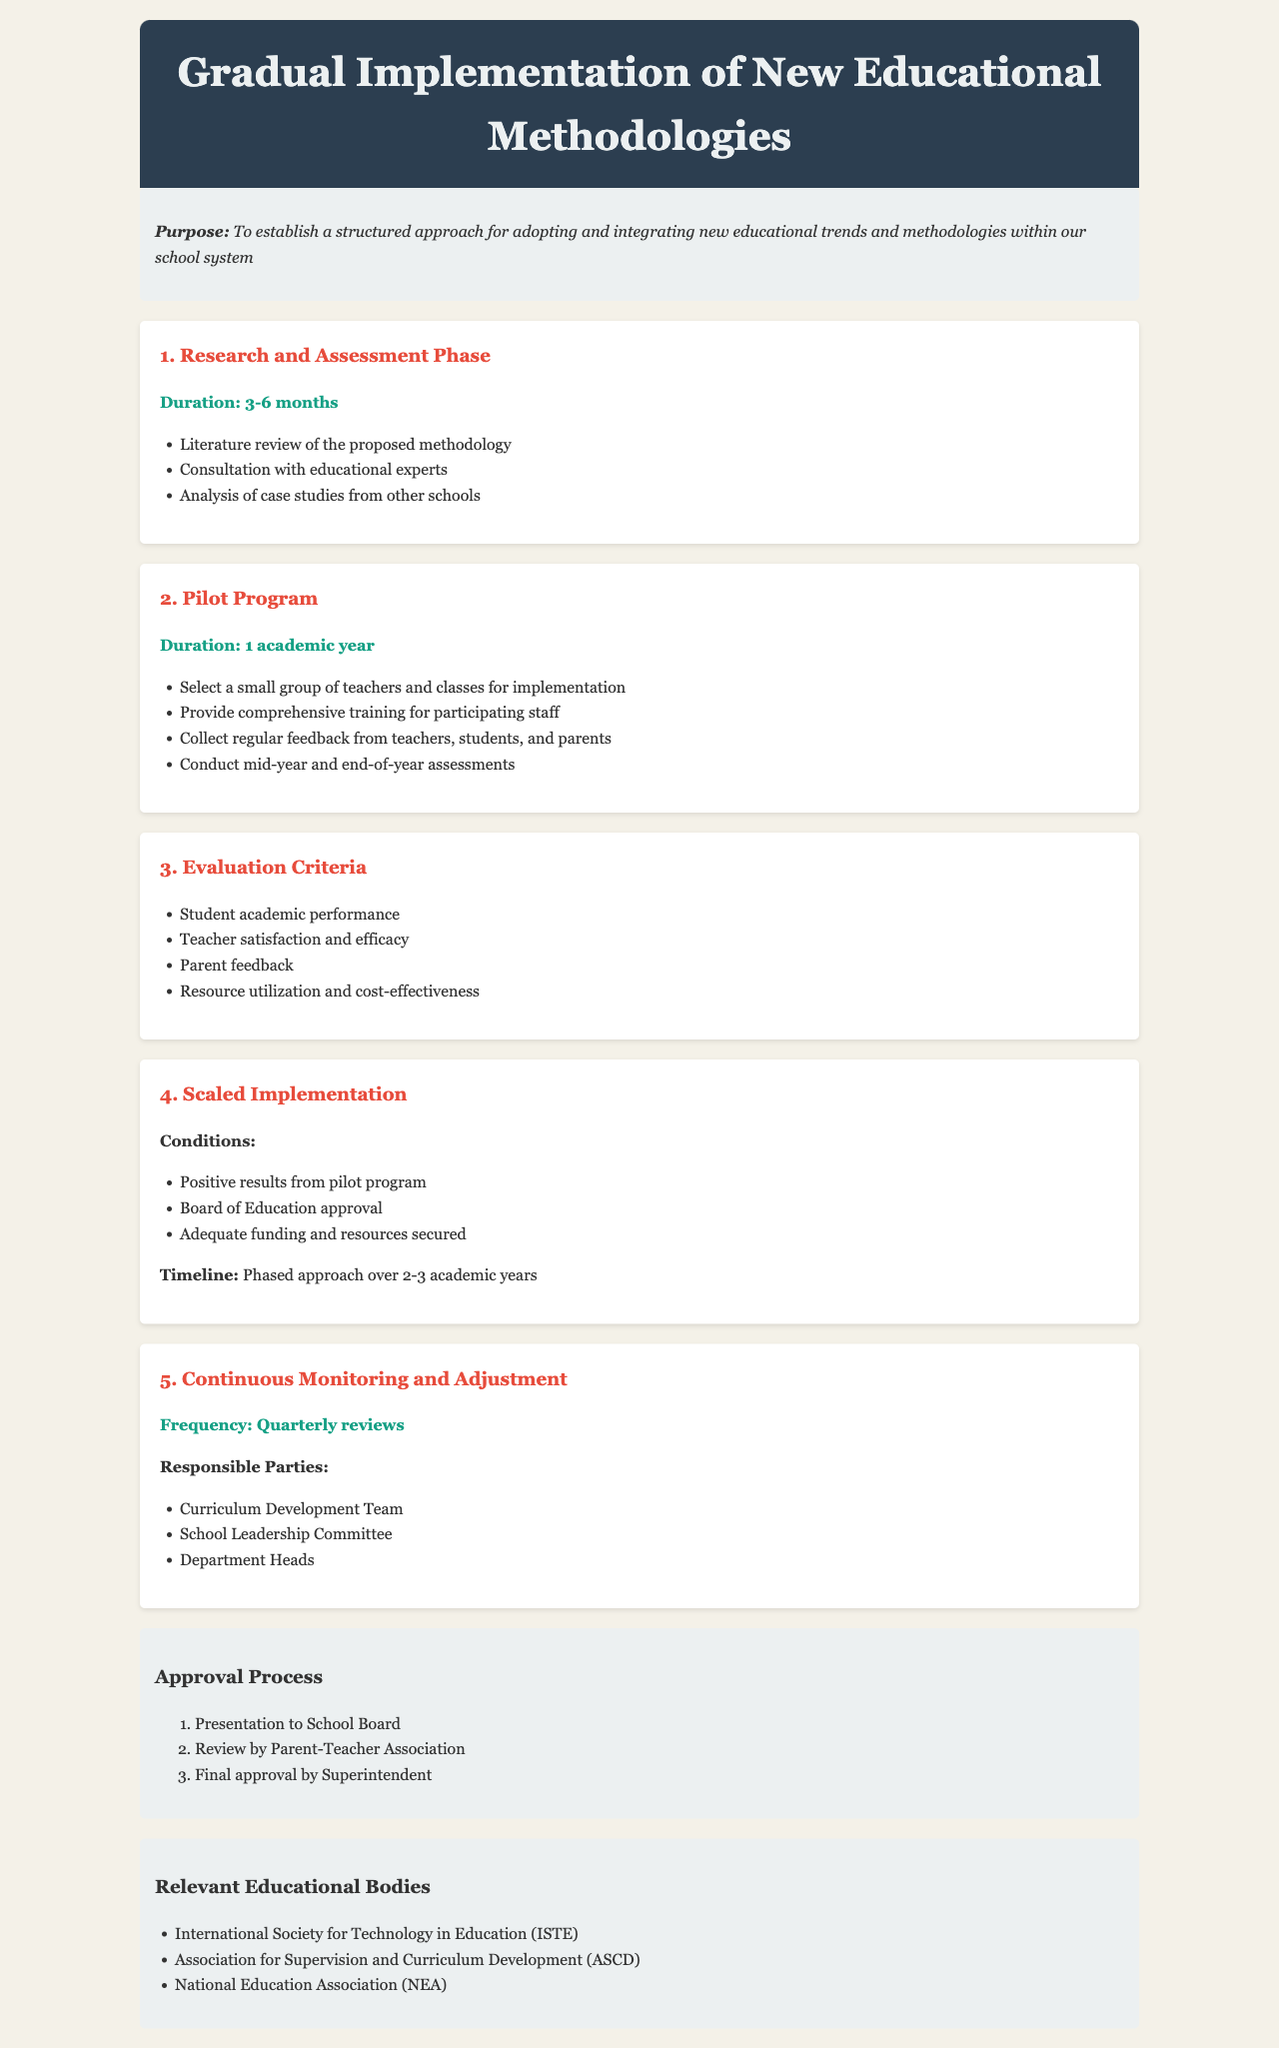What is the duration for the Research and Assessment Phase? The document specifies that the duration for the Research and Assessment Phase is between 3 to 6 months.
Answer: 3-6 months What are the evaluation criteria listed in the document? The evaluation criteria include student academic performance, teacher satisfaction and efficacy, parent feedback, and resource utilization and cost-effectiveness.
Answer: Student academic performance, teacher satisfaction and efficacy, parent feedback, resource utilization and cost-effectiveness How long will the pilot program last? According to the document, the pilot program is set to last for one academic year.
Answer: 1 academic year What is required for the scaled implementation to begin? The document states that positive results from the pilot program, Board of Education approval, and adequate funding and resources secured are required for scaled implementation.
Answer: Positive results from pilot program, Board of Education approval, adequate funding and resources How frequently will the Continuous Monitoring and Adjustment occur? The document indicates that Continuous Monitoring and Adjustment will take place quarterly.
Answer: Quarterly Who are the responsible parties for monitoring and adjustment? The document lists the Curriculum Development Team, School Leadership Committee, and Department Heads as responsible parties.
Answer: Curriculum Development Team, School Leadership Committee, Department Heads 